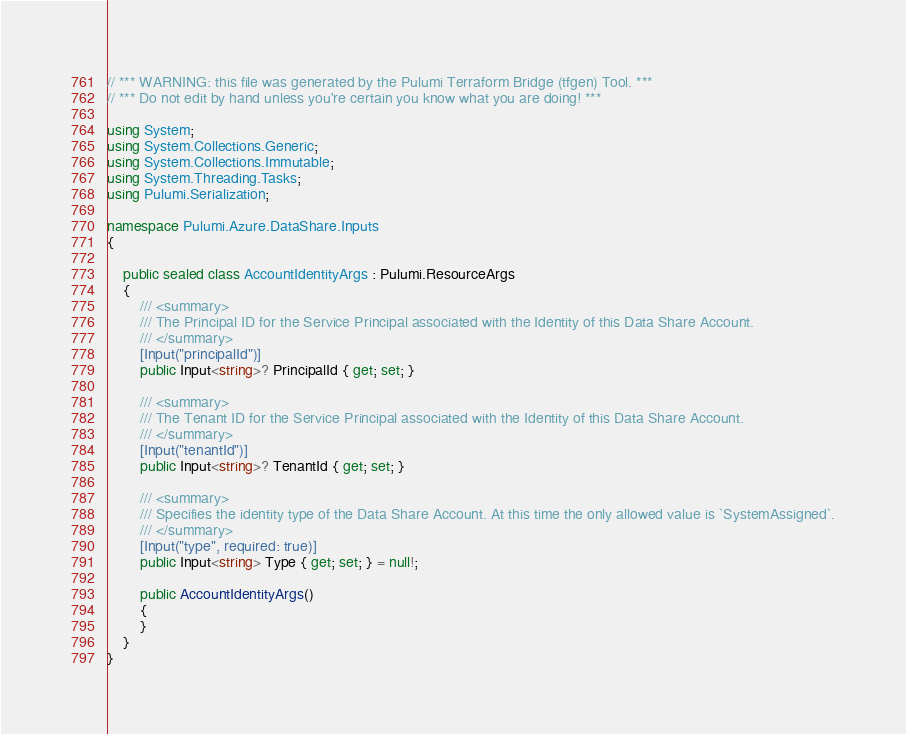<code> <loc_0><loc_0><loc_500><loc_500><_C#_>// *** WARNING: this file was generated by the Pulumi Terraform Bridge (tfgen) Tool. ***
// *** Do not edit by hand unless you're certain you know what you are doing! ***

using System;
using System.Collections.Generic;
using System.Collections.Immutable;
using System.Threading.Tasks;
using Pulumi.Serialization;

namespace Pulumi.Azure.DataShare.Inputs
{

    public sealed class AccountIdentityArgs : Pulumi.ResourceArgs
    {
        /// <summary>
        /// The Principal ID for the Service Principal associated with the Identity of this Data Share Account.
        /// </summary>
        [Input("principalId")]
        public Input<string>? PrincipalId { get; set; }

        /// <summary>
        /// The Tenant ID for the Service Principal associated with the Identity of this Data Share Account.
        /// </summary>
        [Input("tenantId")]
        public Input<string>? TenantId { get; set; }

        /// <summary>
        /// Specifies the identity type of the Data Share Account. At this time the only allowed value is `SystemAssigned`.
        /// </summary>
        [Input("type", required: true)]
        public Input<string> Type { get; set; } = null!;

        public AccountIdentityArgs()
        {
        }
    }
}
</code> 